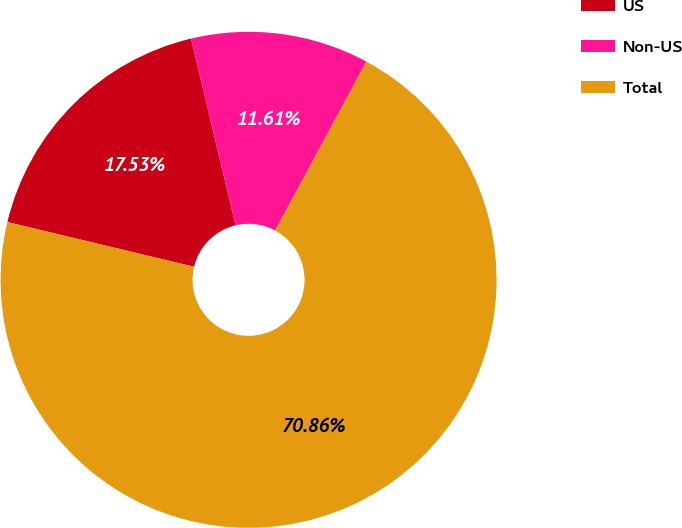Convert chart to OTSL. <chart><loc_0><loc_0><loc_500><loc_500><pie_chart><fcel>US<fcel>Non-US<fcel>Total<nl><fcel>17.53%<fcel>11.61%<fcel>70.86%<nl></chart> 